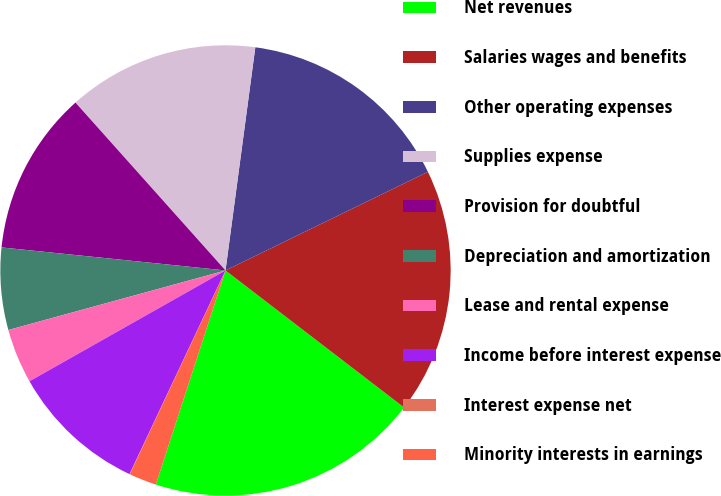Convert chart to OTSL. <chart><loc_0><loc_0><loc_500><loc_500><pie_chart><fcel>Net revenues<fcel>Salaries wages and benefits<fcel>Other operating expenses<fcel>Supplies expense<fcel>Provision for doubtful<fcel>Depreciation and amortization<fcel>Lease and rental expense<fcel>Income before interest expense<fcel>Interest expense net<fcel>Minority interests in earnings<nl><fcel>19.59%<fcel>17.63%<fcel>15.67%<fcel>13.72%<fcel>11.76%<fcel>5.89%<fcel>3.93%<fcel>9.8%<fcel>0.02%<fcel>1.98%<nl></chart> 